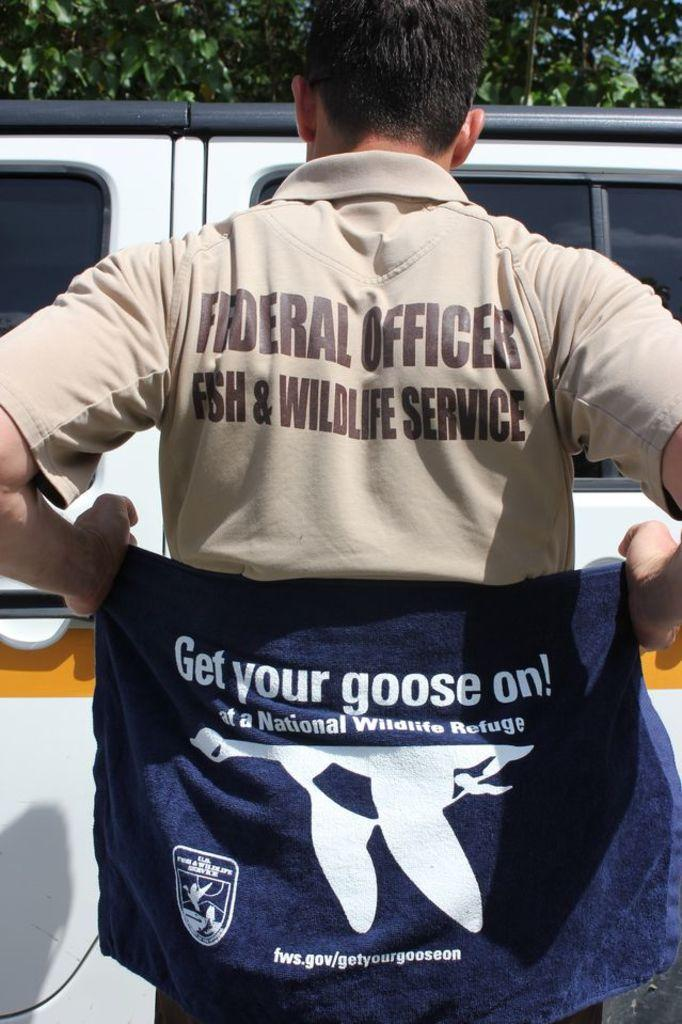<image>
Describe the image concisely. a person wearing a federal offices shirt on their back outside 